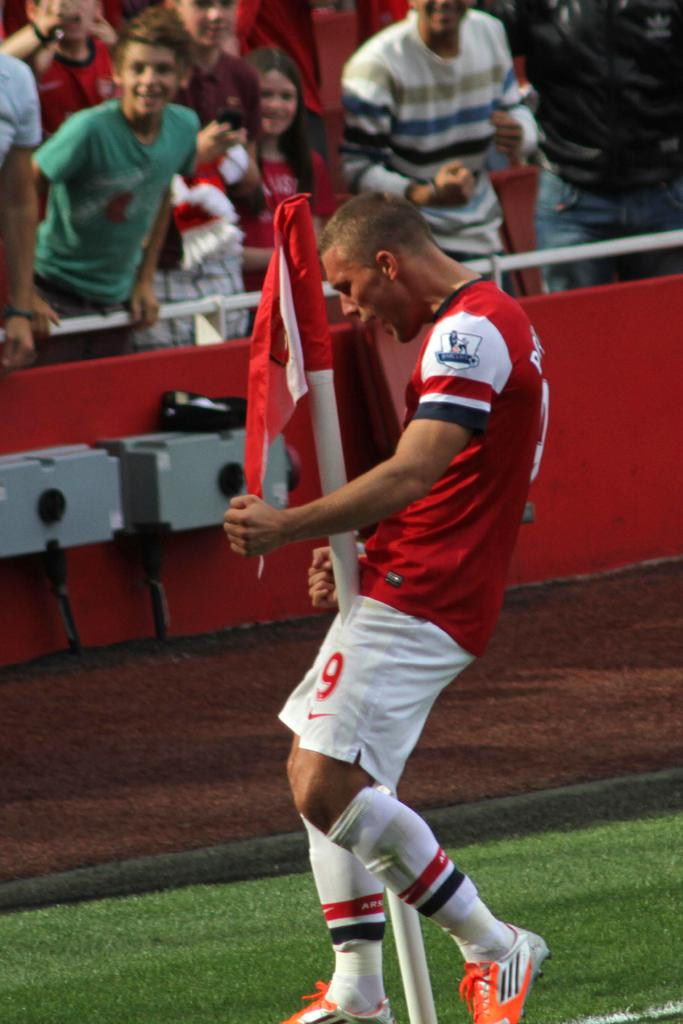Provide a one-sentence caption for the provided image. a player with the number 9 on their shorts. 